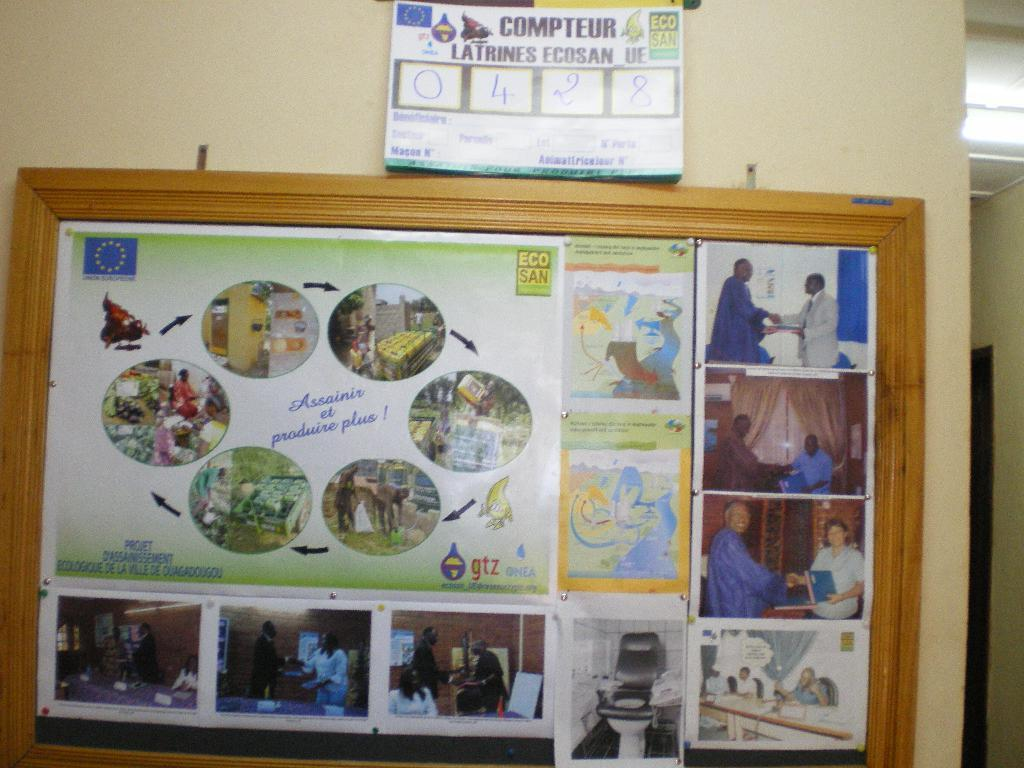<image>
Share a concise interpretation of the image provided. A framed series of pictures of a series of steps of an experiment with the numbers 0428 at the top. 